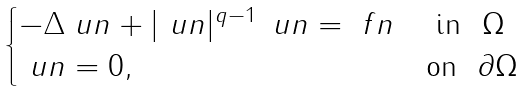<formula> <loc_0><loc_0><loc_500><loc_500>\begin{cases} - \Delta \ u n + | \ u n | ^ { q - 1 } \, \ u n = \ f n & \ \text {in } \ \Omega \\ \ u n = 0 , & \text {on } \ \partial \Omega \end{cases}</formula> 